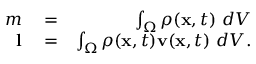<formula> <loc_0><loc_0><loc_500><loc_500>\begin{array} { r l r } { m } & = } & { \int _ { \Omega } \rho ( x , t ) \ d V } \\ { l } & = } & { \int _ { \Omega } \rho ( x , t ) v ( x , t ) \ d V . } \end{array}</formula> 